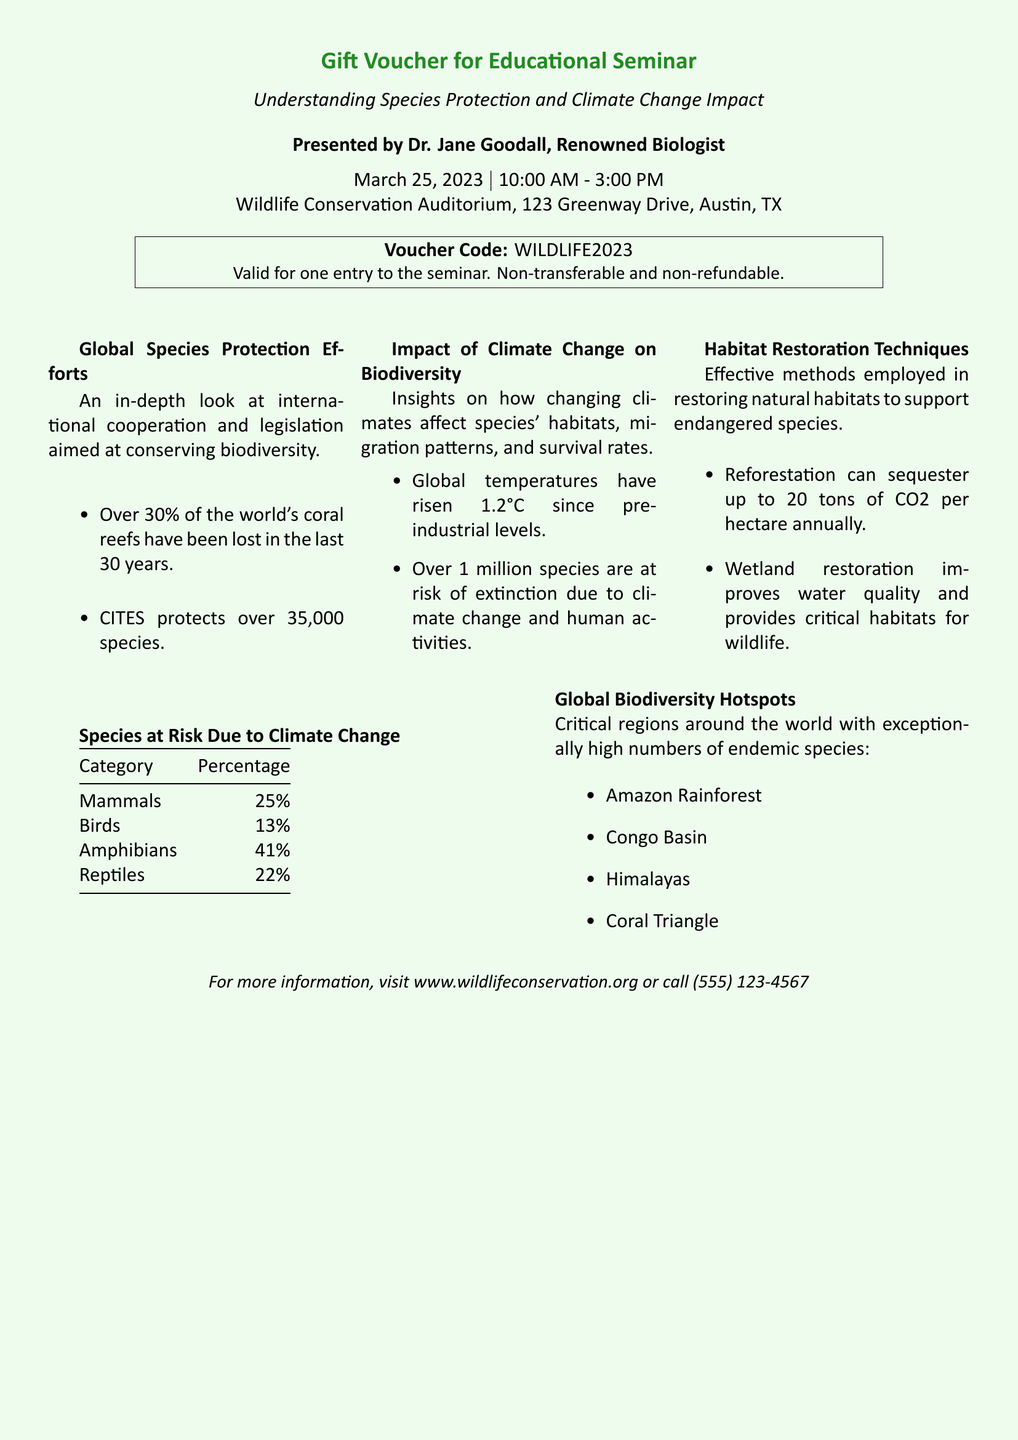What is the title of the seminar? The title of the seminar is mentioned as "Understanding Species Protection and Climate Change Impact."
Answer: Understanding Species Protection and Climate Change Impact Who is presenting the seminar? The document states that the seminar is presented by Dr. Jane Goodall, a renowned biologist.
Answer: Dr. Jane Goodall What is the date of the seminar? The date of the seminar is explicitly stated in the document as March 25, 2023.
Answer: March 25, 2023 What is the voucher code? The document includes a specific voucher code which is WILDLIFE2023.
Answer: WILDLIFE2023 What percentage of mammals is at risk due to climate change? The document lists the percentage of mammals at risk as 25%.
Answer: 25% How long is the seminar scheduled to run? The seminar is scheduled from 10:00 AM to 3:00 PM, totaling 5 hours.
Answer: 5 hours Which region is mentioned as a global biodiversity hotspot? The document lists several regions, one of them being the Amazon Rainforest.
Answer: Amazon Rainforest What is one habitat restoration technique mentioned? The document identifies reforestation as one of the habitat restoration techniques mentioned.
Answer: Reforestation What is the venue of the seminar? The seminar is scheduled to be held at the Wildlife Conservation Auditorium, 123 Greenway Drive, Austin, TX.
Answer: Wildlife Conservation Auditorium, 123 Greenway Drive, Austin, TX 